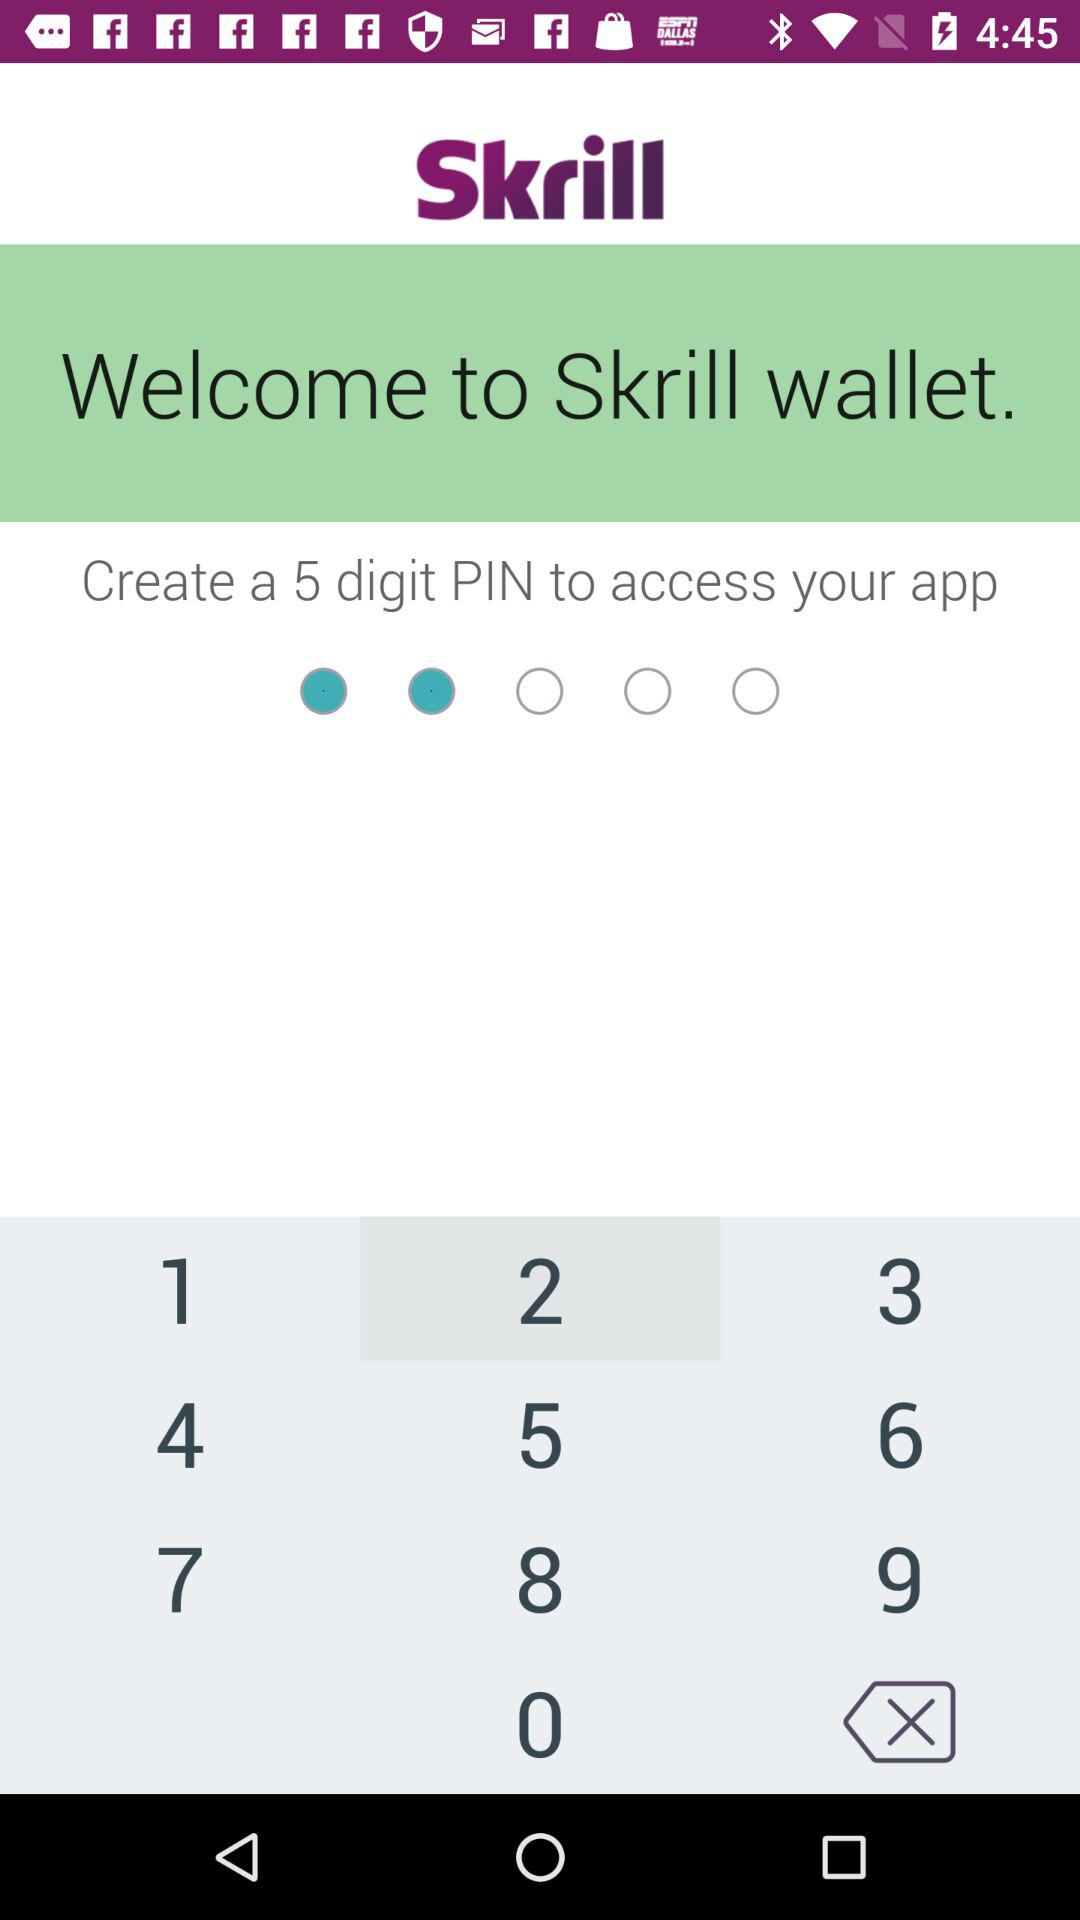What is the application name? The application name is "Skrill". 